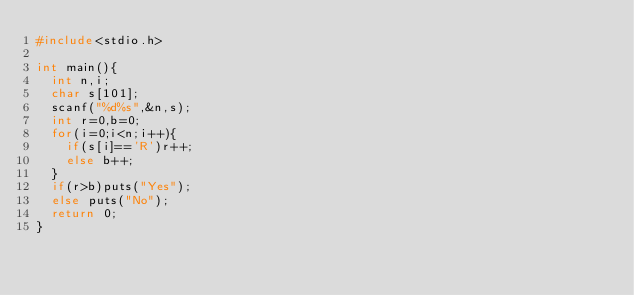Convert code to text. <code><loc_0><loc_0><loc_500><loc_500><_C_>#include<stdio.h>

int main(){
	int n,i;
	char s[101];
	scanf("%d%s",&n,s);
	int r=0,b=0;
	for(i=0;i<n;i++){
		if(s[i]=='R')r++;
		else b++;
	}
	if(r>b)puts("Yes");
	else puts("No");
	return 0;
}</code> 